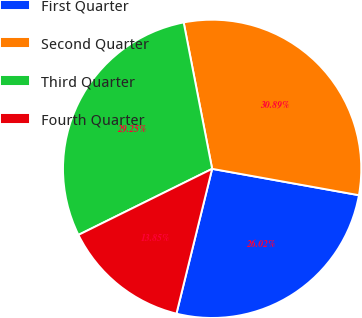<chart> <loc_0><loc_0><loc_500><loc_500><pie_chart><fcel>First Quarter<fcel>Second Quarter<fcel>Third Quarter<fcel>Fourth Quarter<nl><fcel>26.02%<fcel>30.89%<fcel>29.25%<fcel>13.85%<nl></chart> 